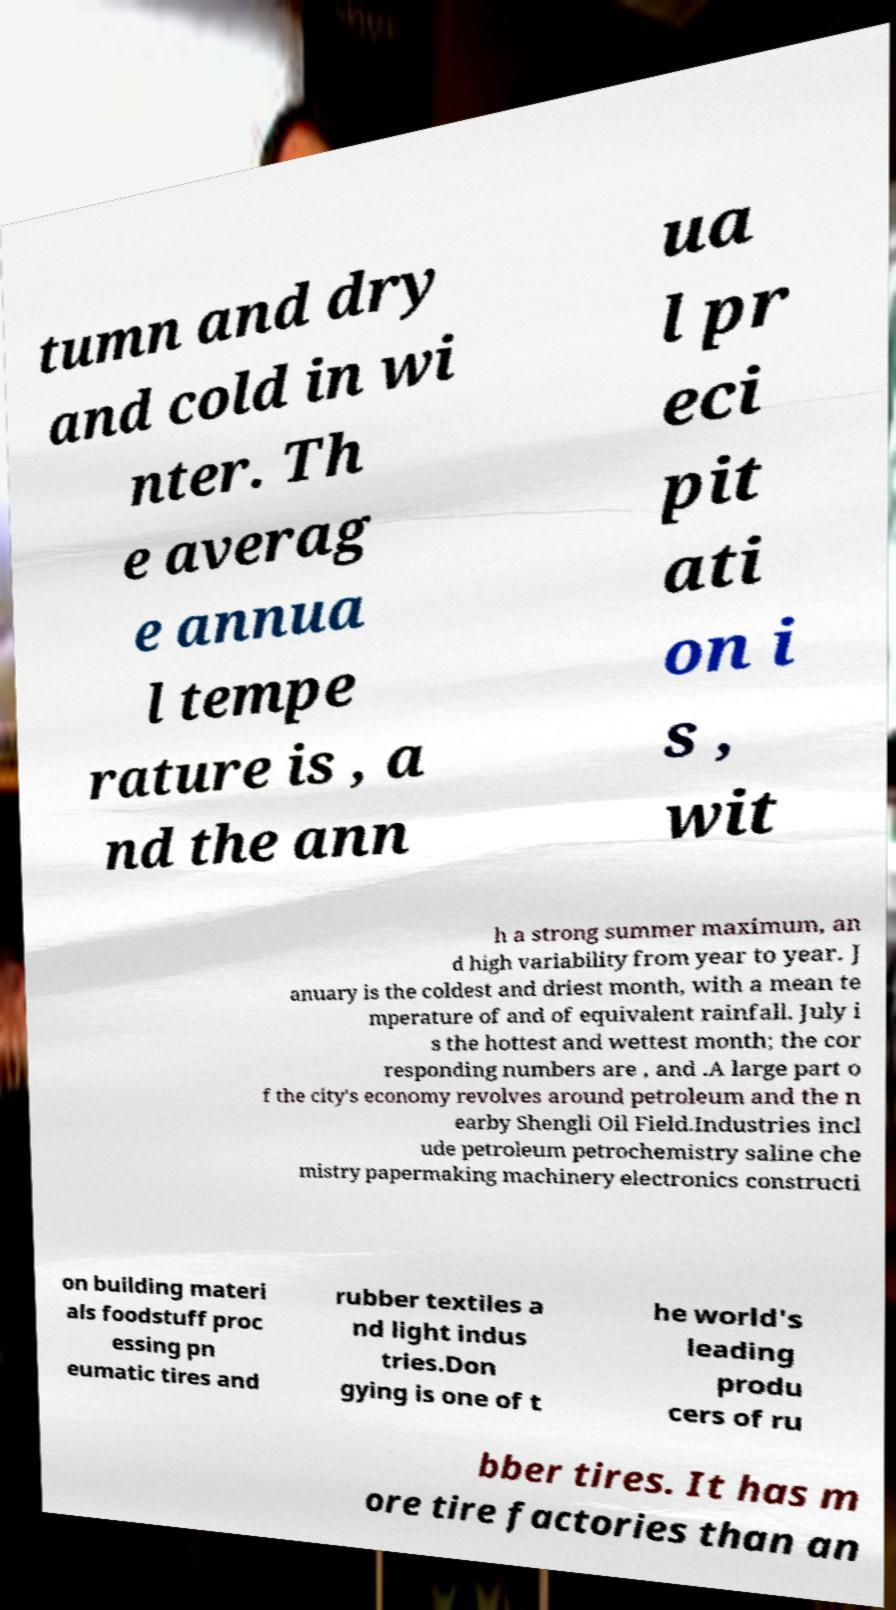Please identify and transcribe the text found in this image. tumn and dry and cold in wi nter. Th e averag e annua l tempe rature is , a nd the ann ua l pr eci pit ati on i s , wit h a strong summer maximum, an d high variability from year to year. J anuary is the coldest and driest month, with a mean te mperature of and of equivalent rainfall. July i s the hottest and wettest month; the cor responding numbers are , and .A large part o f the city's economy revolves around petroleum and the n earby Shengli Oil Field.Industries incl ude petroleum petrochemistry saline che mistry papermaking machinery electronics constructi on building materi als foodstuff proc essing pn eumatic tires and rubber textiles a nd light indus tries.Don gying is one of t he world's leading produ cers of ru bber tires. It has m ore tire factories than an 